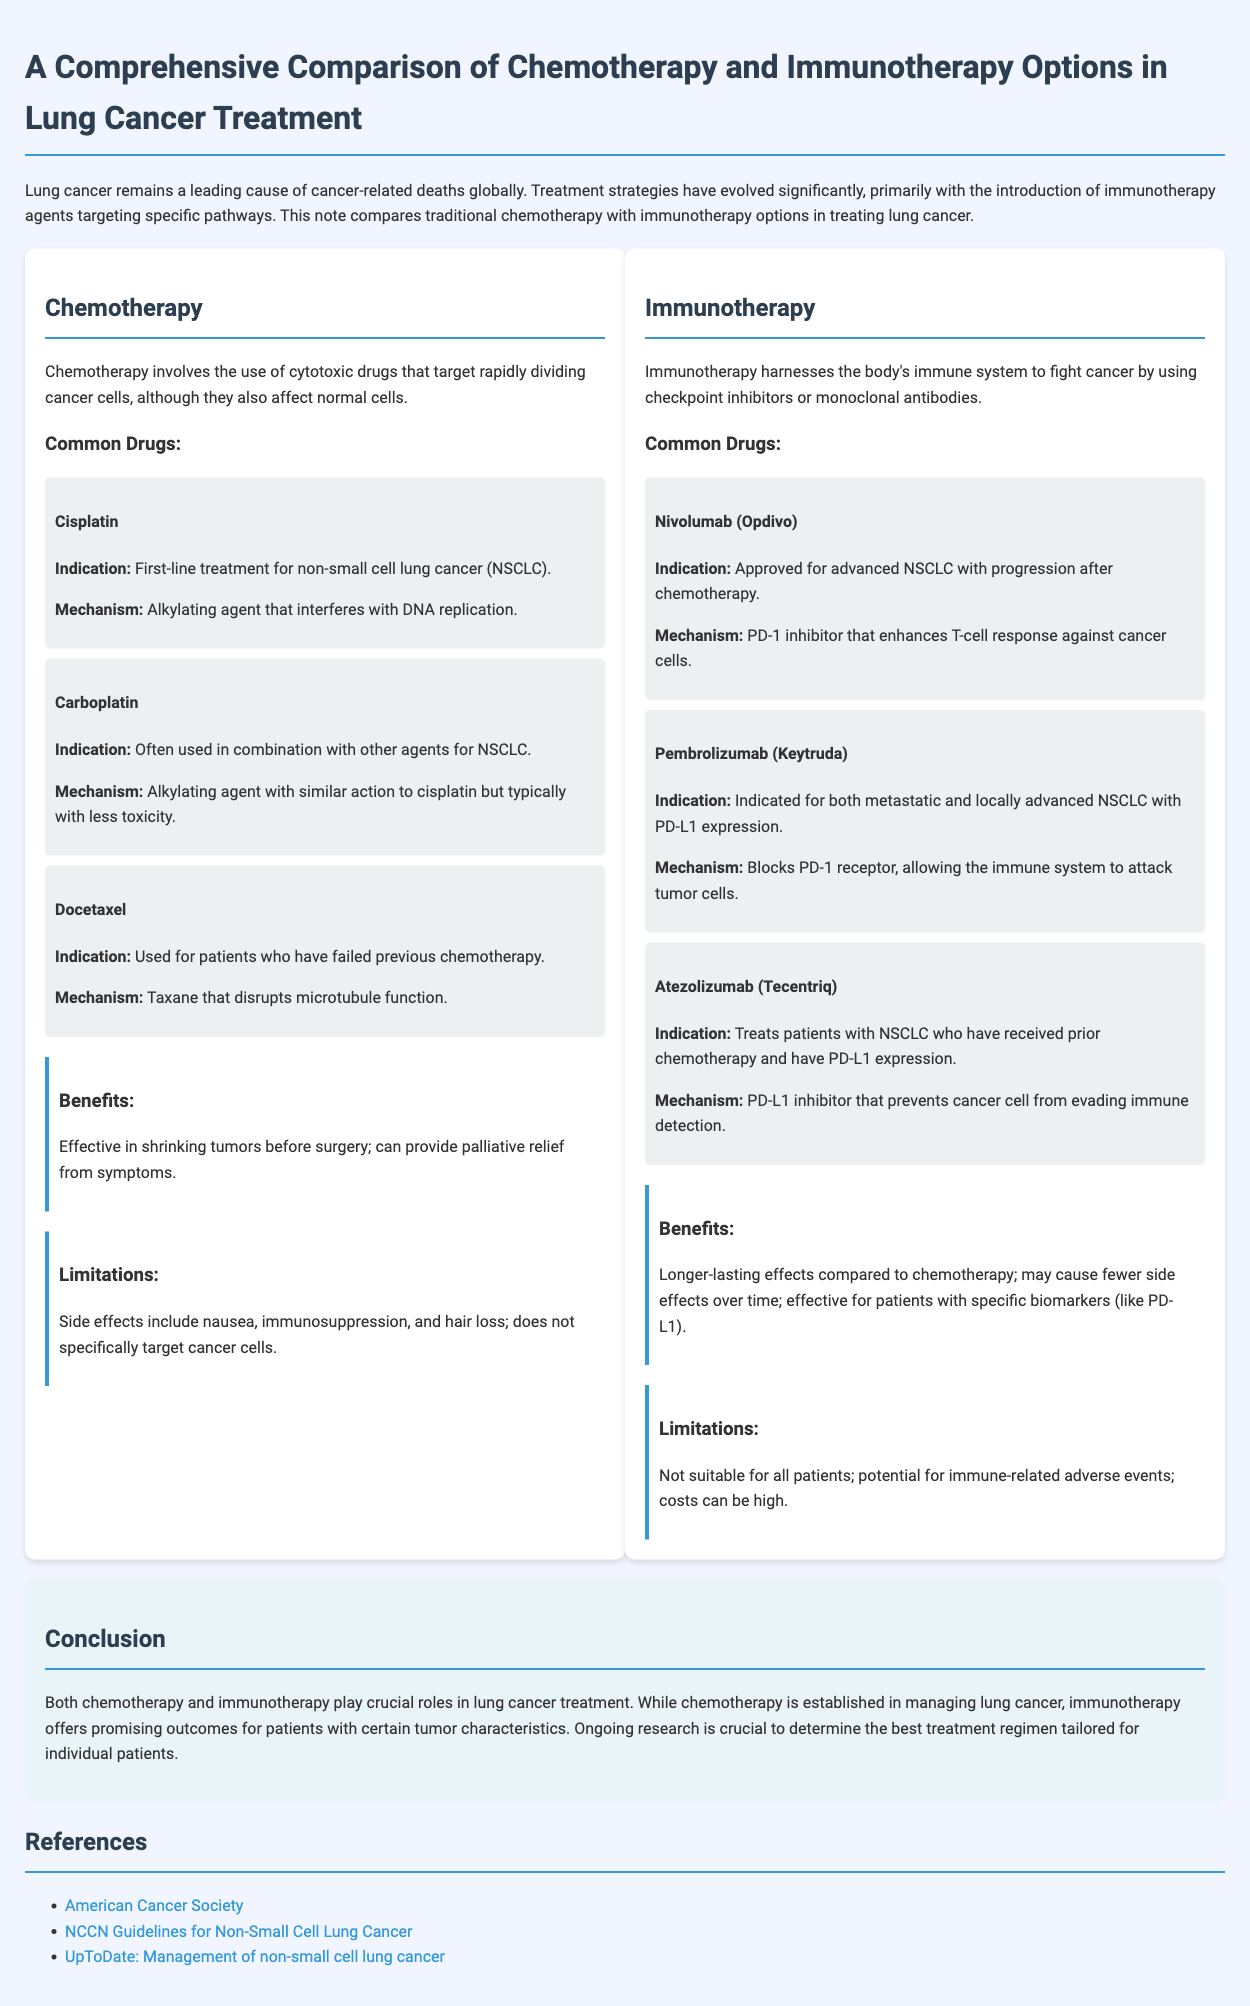what is the first-line treatment for NSCLC? The document states that Cisplatin is indicated as the first-line treatment for non-small cell lung cancer.
Answer: Cisplatin what mechanism does Nivolumab use? Nivolumab is a PD-1 inhibitor that enhances T-cell response against cancer cells, as mentioned in the document.
Answer: PD-1 inhibitor what is a common side effect of chemotherapy? The document lists nausea as one of the side effects of chemotherapy, highlighting its impact on patients.
Answer: Nausea which immunotherapy drug targets PD-L1? Atezolizumab is specifically mentioned as a PD-L1 inhibitor in the document.
Answer: Atezolizumab what are the benefits of immunotherapy compared to chemotherapy? The note explains that immunotherapy can provide longer-lasting effects and may cause fewer side effects over time.
Answer: Longer-lasting effects what is the role of chemotherapy in lung cancer treatment? The document describes chemotherapy as effective in shrinking tumors and providing palliative relief from symptoms.
Answer: Shrinking tumors which treatment is not suitable for all patients? The note indicates that immunotherapy is not suitable for all patients due to various factors.
Answer: Immunotherapy how does Docetaxel function? Docetaxel is described in the document as a taxane that disrupts microtubule function.
Answer: Disrupts microtubule function what type of document is this? The content is structured as a comparison note detailing two treatment options for lung cancer.
Answer: Comparison note 